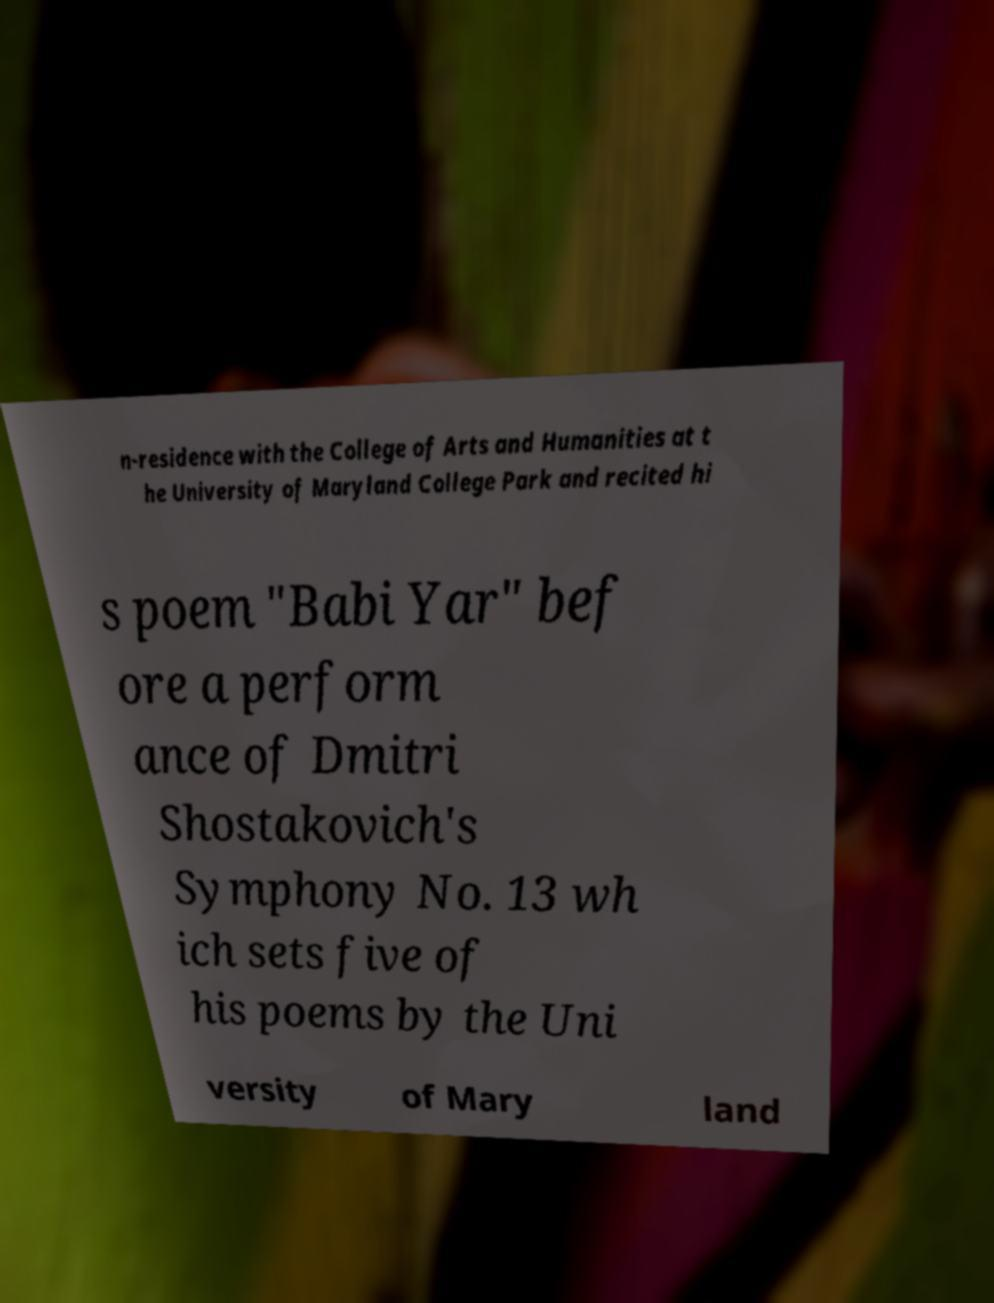There's text embedded in this image that I need extracted. Can you transcribe it verbatim? n-residence with the College of Arts and Humanities at t he University of Maryland College Park and recited hi s poem "Babi Yar" bef ore a perform ance of Dmitri Shostakovich's Symphony No. 13 wh ich sets five of his poems by the Uni versity of Mary land 